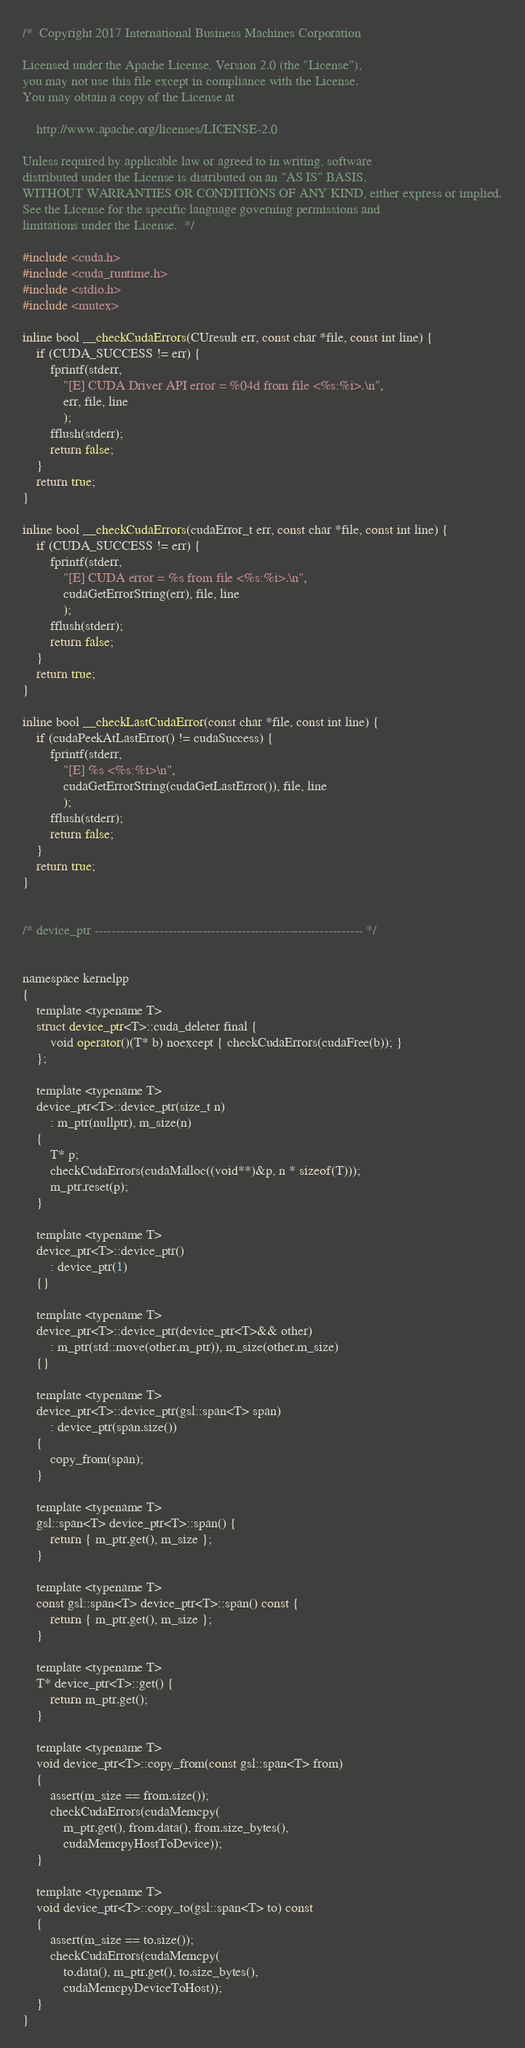<code> <loc_0><loc_0><loc_500><loc_500><_Cuda_>/*  Copyright 2017 International Business Machines Corporation

Licensed under the Apache License, Version 2.0 (the "License");
you may not use this file except in compliance with the License.
You may obtain a copy of the License at

    http://www.apache.org/licenses/LICENSE-2.0

Unless required by applicable law or agreed to in writing, software
distributed under the License is distributed on an "AS IS" BASIS,
WITHOUT WARRANTIES OR CONDITIONS OF ANY KIND, either express or implied.
See the License for the specific language governing permissions and
limitations under the License.  */

#include <cuda.h>
#include <cuda_runtime.h>
#include <stdio.h>
#include <mutex>

inline bool __checkCudaErrors(CUresult err, const char *file, const int line) {
    if (CUDA_SUCCESS != err) {
        fprintf(stderr,
            "[E] CUDA Driver API error = %04d from file <%s:%i>.\n",
            err, file, line
            );
        fflush(stderr);
        return false;
    }
    return true;
}

inline bool __checkCudaErrors(cudaError_t err, const char *file, const int line) {
    if (CUDA_SUCCESS != err) {
        fprintf(stderr,
            "[E] CUDA error = %s from file <%s:%i>.\n",
            cudaGetErrorString(err), file, line
            );
        fflush(stderr);
        return false;
    }
    return true;
}

inline bool __checkLastCudaError(const char *file, const int line) {
    if (cudaPeekAtLastError() != cudaSuccess) {
        fprintf(stderr,
            "[E] %s <%s:%i>\n",
            cudaGetErrorString(cudaGetLastError()), file, line
            );
        fflush(stderr);
        return false;
    }
    return true;
}


/* device_ptr -------------------------------------------------------------- */


namespace kernelpp
{
    template <typename T>
    struct device_ptr<T>::cuda_deleter final {
        void operator()(T* b) noexcept { checkCudaErrors(cudaFree(b)); }
    };

    template <typename T>
    device_ptr<T>::device_ptr(size_t n)
        : m_ptr(nullptr), m_size(n)
    {
        T* p;
        checkCudaErrors(cudaMalloc((void**)&p, n * sizeof(T)));
        m_ptr.reset(p);
    }

    template <typename T>
    device_ptr<T>::device_ptr()
        : device_ptr(1)
    {}

    template <typename T>
    device_ptr<T>::device_ptr(device_ptr<T>&& other)
        : m_ptr(std::move(other.m_ptr)), m_size(other.m_size)
    {}

    template <typename T>
    device_ptr<T>::device_ptr(gsl::span<T> span)
        : device_ptr(span.size())
    {
        copy_from(span);
    }

    template <typename T>
    gsl::span<T> device_ptr<T>::span() {
        return { m_ptr.get(), m_size };
    }

    template <typename T>
    const gsl::span<T> device_ptr<T>::span() const {
        return { m_ptr.get(), m_size };
    }

    template <typename T>
    T* device_ptr<T>::get() {
        return m_ptr.get();
    }

    template <typename T>
    void device_ptr<T>::copy_from(const gsl::span<T> from)
    {
        assert(m_size == from.size());
        checkCudaErrors(cudaMemcpy(
            m_ptr.get(), from.data(), from.size_bytes(),
            cudaMemcpyHostToDevice));
    }

    template <typename T>
    void device_ptr<T>::copy_to(gsl::span<T> to) const
    {
        assert(m_size == to.size());
        checkCudaErrors(cudaMemcpy(
            to.data(), m_ptr.get(), to.size_bytes(),
            cudaMemcpyDeviceToHost));
    }
}
</code> 